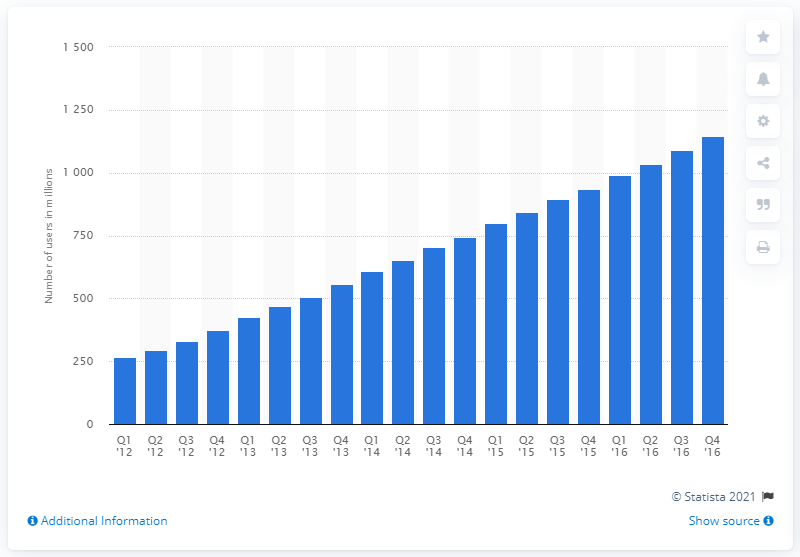Give some essential details in this illustration. It is estimated that approximately 1,146 active users visited Facebook on a daily basis. 